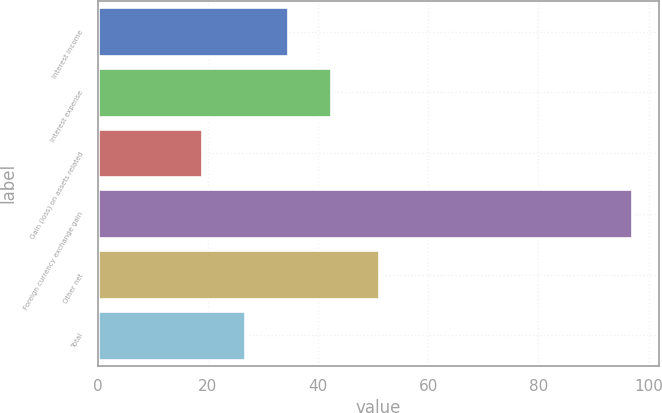<chart> <loc_0><loc_0><loc_500><loc_500><bar_chart><fcel>Interest income<fcel>Interest expense<fcel>Gain (loss) on assets related<fcel>Foreign currency exchange gain<fcel>Other net<fcel>Total<nl><fcel>34.6<fcel>42.4<fcel>19<fcel>97<fcel>51<fcel>26.8<nl></chart> 